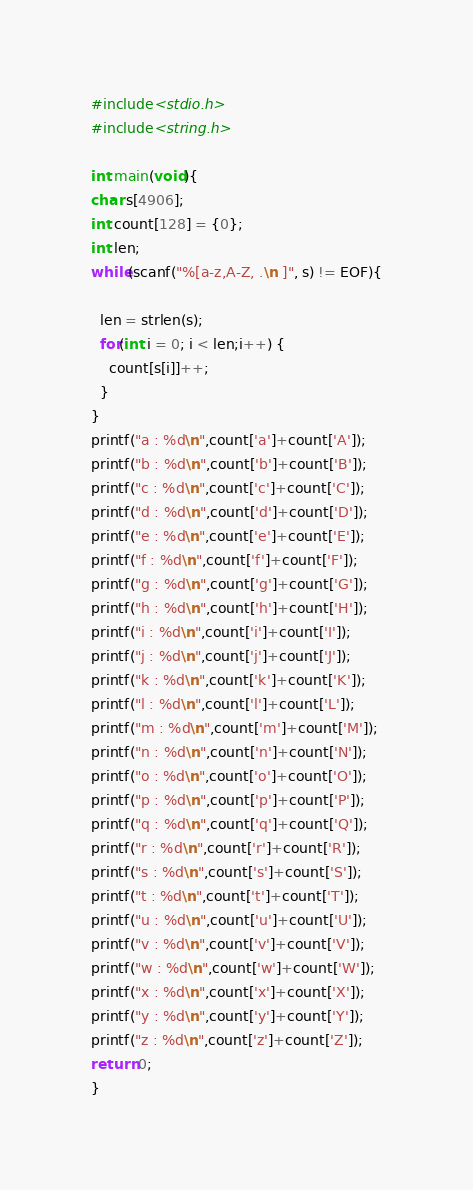<code> <loc_0><loc_0><loc_500><loc_500><_C_>#include<stdio.h>
#include<string.h>

int main(void){
char s[4906];
int count[128] = {0};
int len;
while(scanf("%[a-z,A-Z, .\n ]", s) != EOF){

  len = strlen(s);
  for(int i = 0; i < len;i++) {
    count[s[i]]++;
  }
}  
printf("a : %d\n",count['a']+count['A']);
printf("b : %d\n",count['b']+count['B']);
printf("c : %d\n",count['c']+count['C']);
printf("d : %d\n",count['d']+count['D']);
printf("e : %d\n",count['e']+count['E']);
printf("f : %d\n",count['f']+count['F']);
printf("g : %d\n",count['g']+count['G']);
printf("h : %d\n",count['h']+count['H']);
printf("i : %d\n",count['i']+count['I']);
printf("j : %d\n",count['j']+count['J']);
printf("k : %d\n",count['k']+count['K']);
printf("l : %d\n",count['l']+count['L']);
printf("m : %d\n",count['m']+count['M']);
printf("n : %d\n",count['n']+count['N']);
printf("o : %d\n",count['o']+count['O']);
printf("p : %d\n",count['p']+count['P']);
printf("q : %d\n",count['q']+count['Q']);
printf("r : %d\n",count['r']+count['R']);
printf("s : %d\n",count['s']+count['S']);
printf("t : %d\n",count['t']+count['T']);
printf("u : %d\n",count['u']+count['U']);
printf("v : %d\n",count['v']+count['V']);
printf("w : %d\n",count['w']+count['W']);
printf("x : %d\n",count['x']+count['X']);
printf("y : %d\n",count['y']+count['Y']);
printf("z : %d\n",count['z']+count['Z']);
return 0;
}

</code> 